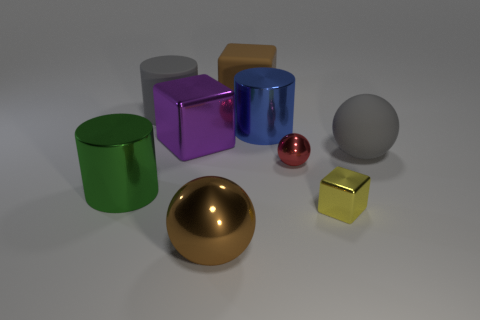What number of objects are yellow blocks or brown balls?
Ensure brevity in your answer.  2. There is a large gray matte object on the right side of the large brown ball; how many rubber blocks are on the left side of it?
Your answer should be very brief. 1. What number of other things are there of the same size as the gray sphere?
Ensure brevity in your answer.  6. Do the gray matte object that is left of the gray sphere and the green object have the same shape?
Your response must be concise. Yes. What is the material of the large blue cylinder on the left side of the large matte ball?
Provide a succinct answer. Metal. What shape is the object that is the same color as the big matte block?
Your answer should be compact. Sphere. Are there any tiny yellow things that have the same material as the large green thing?
Your answer should be very brief. Yes. What size is the blue thing?
Provide a short and direct response. Large. How many blue objects are large matte cylinders or small metallic balls?
Make the answer very short. 0. What number of blue metal objects are the same shape as the big green object?
Offer a terse response. 1. 